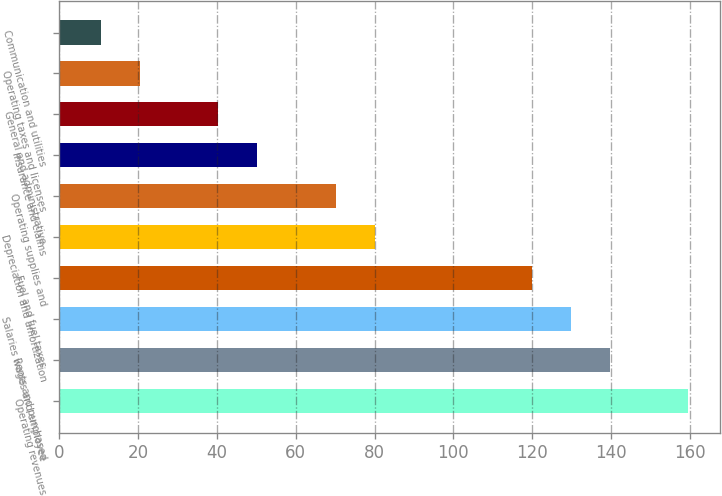<chart> <loc_0><loc_0><loc_500><loc_500><bar_chart><fcel>Operating revenues<fcel>Rents and purchased<fcel>Salaries wages and employee<fcel>Fuel and fuel taxes<fcel>Depreciation and amortization<fcel>Operating supplies and<fcel>Insurance and claims<fcel>General and administrative<fcel>Operating taxes and licenses<fcel>Communication and utilities<nl><fcel>159.6<fcel>139.72<fcel>129.78<fcel>119.84<fcel>80.08<fcel>70.14<fcel>50.26<fcel>40.32<fcel>20.44<fcel>10.5<nl></chart> 